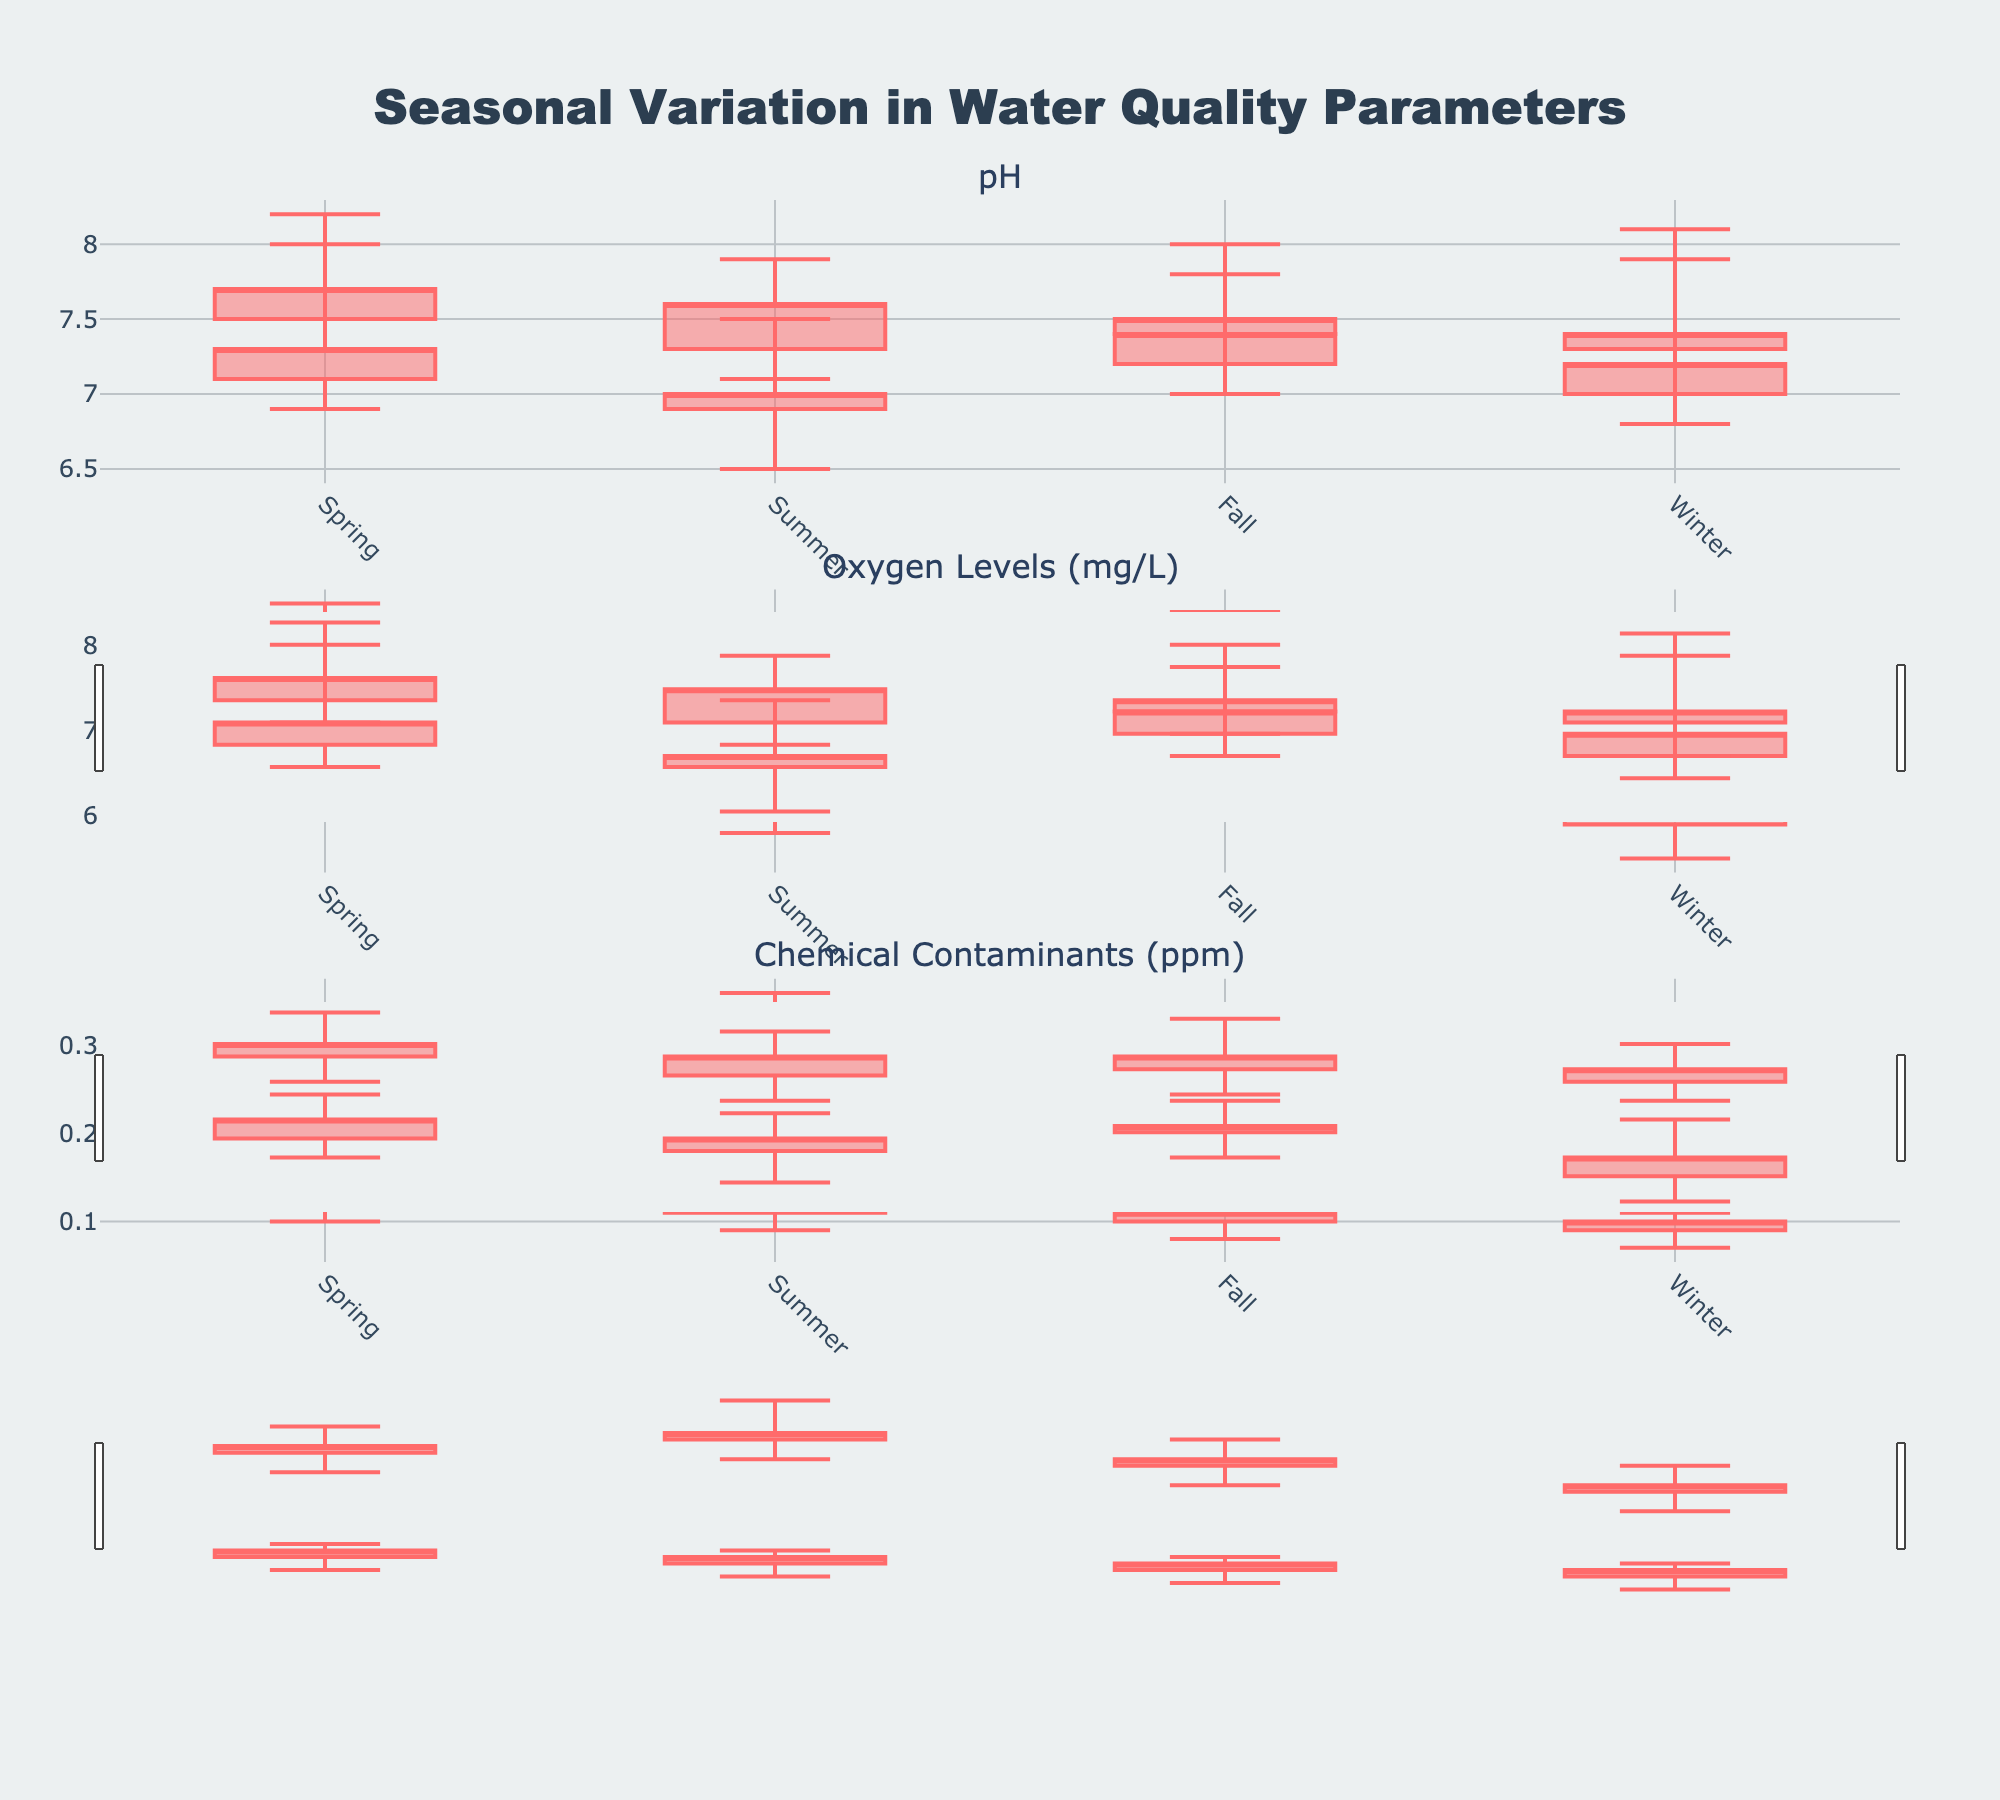What is the title of the figure? The title of the figure is usually displayed at the top of the image. In this case, it reads "Seasonal Variation in Water Quality Parameters".
Answer: Seasonal Variation in Water Quality Parameters Compare the pH levels in River A (Industrial) and River B (Non-Industrial) during Spring. Which one has a higher close value? According to the candlestick plots for pH levels, you can see the closing values for River A (Industrial) and River B (Non-Industrial) during Spring. For River A (Industrial), the close value is 7.3, and for River B (Non-Industrial), it is 7.7.
Answer: River B (Non-Industrial) What is the range of Oxygen Levels in Lake X (Industrial) during Winter? The range of a candlestick plot is calculated by subtracting the low value from the high value. For Lake X (Industrial) during Winter, the high value is 6.8, and the low value is 5.5. Therefore, 6.8 - 5.5 = 1.3.
Answer: 1.3 Which season shows the highest pH value for River A (Industrial)? To find the highest pH value, look at the upper wick (high value) for each season in River A (Industrial). The highest pH value is in Winter with a high of 8.1.
Answer: Winter Compare the chemical contaminant levels in Creek C (Industrial) and Creek D (Non-Industrial) during Summer. Which has a higher high value? Look at the high values in the candlestick plots for chemical contaminants during Summer. For Creek C (Industrial), the high value is 0.36 ppm, and for Creek D (Non-Industrial), it is 0.13 ppm.
Answer: Creek C (Industrial) What is the median close value for Oxygen Levels in Lake Y (Non-Industrial) across all seasons? To find the median, list the close values for all seasons and find the middle value. Close values are 8.0, 7.8, 7.8, and 7.6. The median (average of the two middle values) is (7.8 + 7.8) / 2 = 7.8.
Answer: 7.8 Which location has the most consistent pH levels throughout the seasons (least variability in close values)? To determine consistency, check for the smallest range in close values for pH levels across seasons. For River A (Industrial), the close values range from 7.0 to 7.4. For River B (Non-Industrial), the close values range from 7.4 to 7.7. River A (Industrial) has a smaller range and is more consistent.
Answer: River A (Industrial) What is the difference in the high values of Oxygen Levels between Summer and Winter in Lake X (Industrial)? Look at the high values for Summer and Winter. For Summer, the high value is 6.9, and for Winter, it is 6.8. The difference is 6.9 - 6.8 = 0.1.
Answer: 0.1 